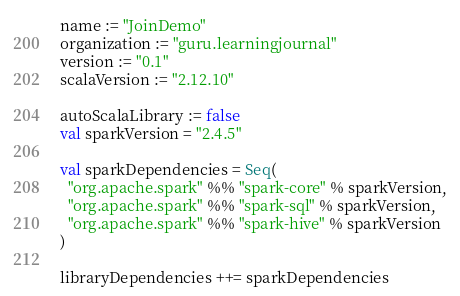Convert code to text. <code><loc_0><loc_0><loc_500><loc_500><_Scala_>name := "JoinDemo"
organization := "guru.learningjournal"
version := "0.1"
scalaVersion := "2.12.10"

autoScalaLibrary := false
val sparkVersion = "2.4.5"

val sparkDependencies = Seq(
  "org.apache.spark" %% "spark-core" % sparkVersion,
  "org.apache.spark" %% "spark-sql" % sparkVersion,
  "org.apache.spark" %% "spark-hive" % sparkVersion
)

libraryDependencies ++= sparkDependencies</code> 